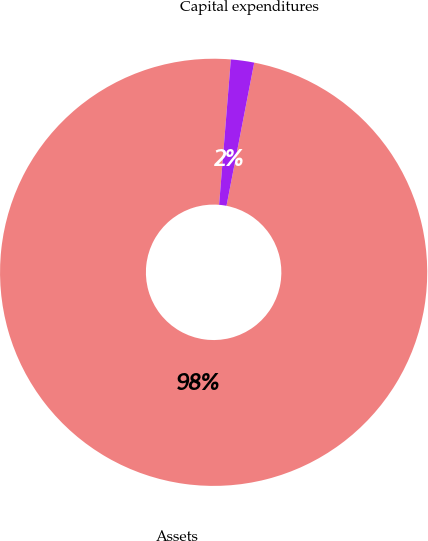Convert chart. <chart><loc_0><loc_0><loc_500><loc_500><pie_chart><fcel>Assets<fcel>Capital expenditures<nl><fcel>98.24%<fcel>1.76%<nl></chart> 